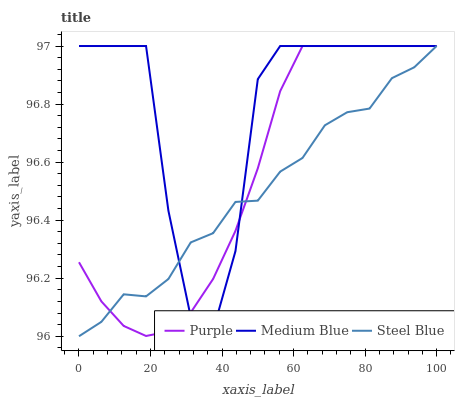Does Steel Blue have the minimum area under the curve?
Answer yes or no. Yes. Does Medium Blue have the maximum area under the curve?
Answer yes or no. Yes. Does Medium Blue have the minimum area under the curve?
Answer yes or no. No. Does Steel Blue have the maximum area under the curve?
Answer yes or no. No. Is Purple the smoothest?
Answer yes or no. Yes. Is Medium Blue the roughest?
Answer yes or no. Yes. Is Steel Blue the smoothest?
Answer yes or no. No. Is Steel Blue the roughest?
Answer yes or no. No. Does Steel Blue have the lowest value?
Answer yes or no. Yes. Does Medium Blue have the lowest value?
Answer yes or no. No. Does Steel Blue have the highest value?
Answer yes or no. Yes. Does Steel Blue intersect Purple?
Answer yes or no. Yes. Is Steel Blue less than Purple?
Answer yes or no. No. Is Steel Blue greater than Purple?
Answer yes or no. No. 